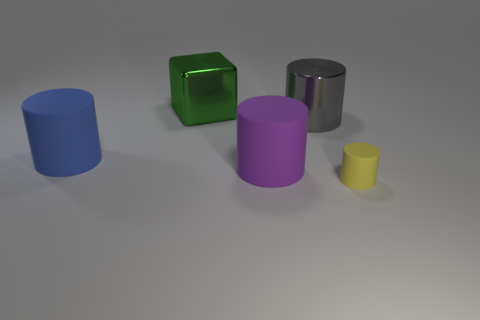Is there any other thing that is the same size as the yellow cylinder?
Offer a very short reply. No. Is there a blue metallic object?
Ensure brevity in your answer.  No. There is a shiny cylinder; is it the same size as the matte object that is right of the gray thing?
Offer a very short reply. No. There is a matte object that is to the left of the large green metallic thing; are there any cylinders behind it?
Ensure brevity in your answer.  Yes. What is the cylinder that is in front of the big blue cylinder and on the left side of the yellow cylinder made of?
Make the answer very short. Rubber. The matte cylinder to the left of the big rubber cylinder in front of the big rubber thing that is left of the big purple cylinder is what color?
Offer a terse response. Blue. What is the color of the metal cylinder that is the same size as the green shiny cube?
Ensure brevity in your answer.  Gray. There is a big object that is in front of the large cylinder to the left of the large purple object; what is its material?
Your answer should be very brief. Rubber. What number of things are in front of the large metallic block and on the left side of the big gray metal cylinder?
Offer a terse response. 2. What number of other things are there of the same size as the purple matte cylinder?
Offer a very short reply. 3. 